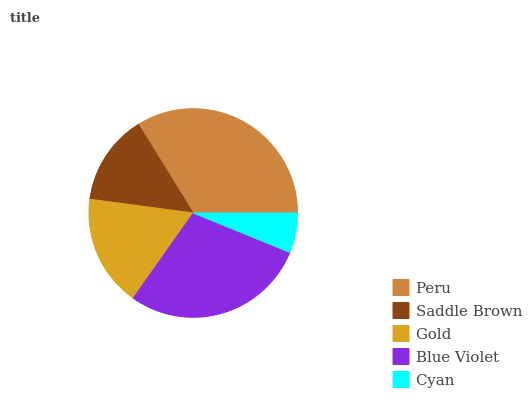Is Cyan the minimum?
Answer yes or no. Yes. Is Peru the maximum?
Answer yes or no. Yes. Is Saddle Brown the minimum?
Answer yes or no. No. Is Saddle Brown the maximum?
Answer yes or no. No. Is Peru greater than Saddle Brown?
Answer yes or no. Yes. Is Saddle Brown less than Peru?
Answer yes or no. Yes. Is Saddle Brown greater than Peru?
Answer yes or no. No. Is Peru less than Saddle Brown?
Answer yes or no. No. Is Gold the high median?
Answer yes or no. Yes. Is Gold the low median?
Answer yes or no. Yes. Is Peru the high median?
Answer yes or no. No. Is Peru the low median?
Answer yes or no. No. 